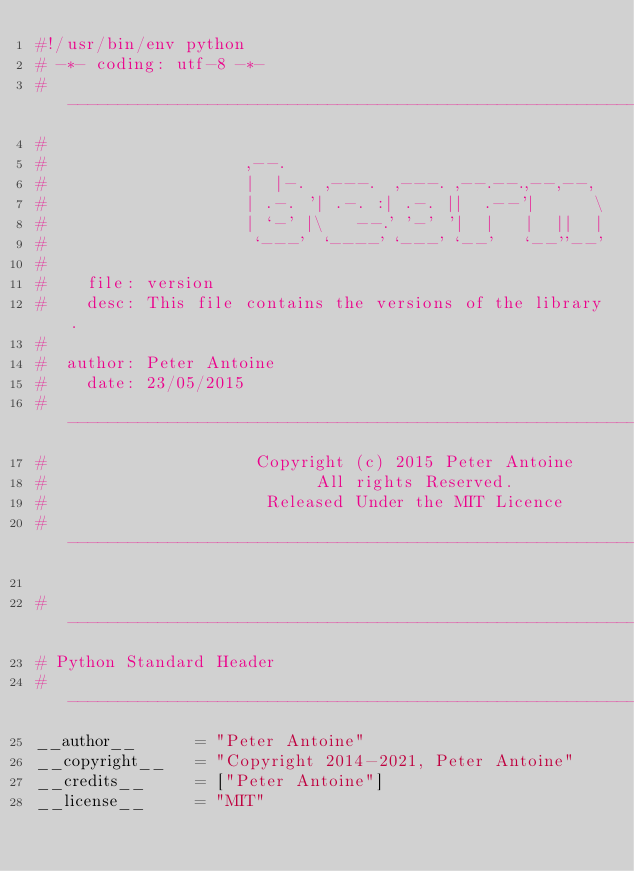Convert code to text. <code><loc_0><loc_0><loc_500><loc_500><_Python_>#!/usr/bin/env python
# -*- coding: utf-8 -*-
#---------------------------------------------------------------------------------
#
#                    ,--.
#                    |  |-.  ,---.  ,---. ,--.--.,--,--,
#                    | .-. '| .-. :| .-. ||  .--'|      \
#                    | `-' |\   --.' '-' '|  |   |  ||  |
#                     `---'  `----' `---' `--'   `--''--'
#
#    file: version
#    desc: This file contains the versions of the library.
#
#  author: Peter Antoine
#    date: 23/05/2015
#---------------------------------------------------------------------------------
#                     Copyright (c) 2015 Peter Antoine
#                           All rights Reserved.
#                      Released Under the MIT Licence
#---------------------------------------------------------------------------------

#---------------------------------------------------------------------------------
# Python Standard Header
#---------------------------------------------------------------------------------
__author__		= "Peter Antoine"
__copyright__	= "Copyright 2014-2021, Peter Antoine"
__credits__		= ["Peter Antoine"]
__license__		= "MIT"</code> 